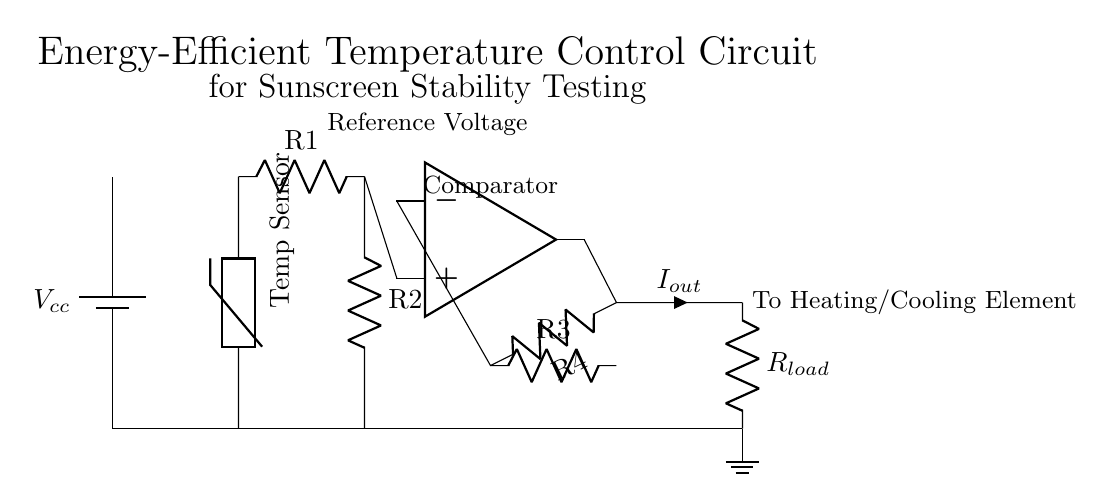What is the power supply voltage in this circuit? The circuit diagram shows a power supply labeled as Vcc, which indicates the voltage supplied to the entire circuit. Without specific numeric values provided in the diagram, we assume the voltage is a typical power supply voltage, commonly 5V or 12V.
Answer: Vcc What type of sensor is used in this circuit? The circuit includes a component labeled as "Temp Sensor" which refers to a thermistor. A thermistor is typically used in temperature sensing applications where resistance changes with temperature.
Answer: Thermistor What is the role of the operational amplifier in this circuit? The operational amplifier in this circuit functions as a comparator, which compares the input voltage derived from the temperature sensor with a reference voltage to control the output. The output regulates the heating or cooling, ensuring a desired temperature for the stability testing.
Answer: Comparator How does R1 and R2 function in this circuit? R1 and R2 form a voltage divider, which is used to set a specific voltage level for the operational amplifier input. They work together to create the proportionate voltage that corresponds to the sensor output, enabling accurate temperature control.
Answer: Voltage divider What is the output current represented as in this circuit? The output current flowing from the operational amplifier is labeled as Iout. This current is significant as it indicates how much current is being supplied to the load, which in this application is likely responsible for heating or cooling elements based on the temperature readings.
Answer: Iout Which component indicates temperature changes at varying levels? The thermistor is the component that senses temperature changes. Its resistance varies with temperature, thus affecting the voltage that reaches the operational amplifier, allowing it to make necessary adjustments for temperature control.
Answer: Thermistor 